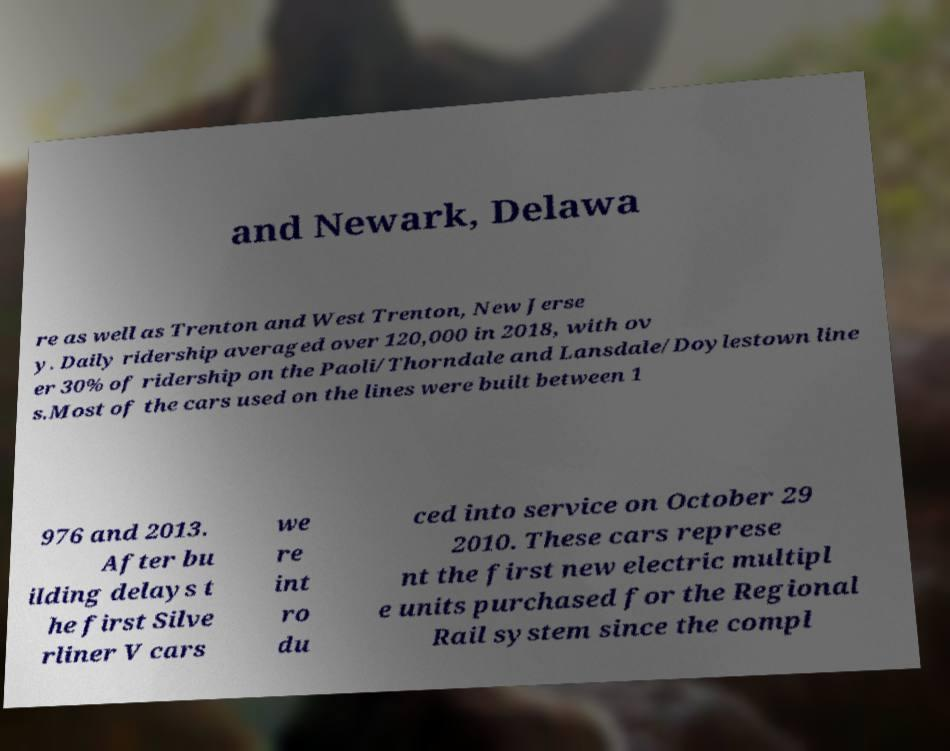Could you assist in decoding the text presented in this image and type it out clearly? and Newark, Delawa re as well as Trenton and West Trenton, New Jerse y. Daily ridership averaged over 120,000 in 2018, with ov er 30% of ridership on the Paoli/Thorndale and Lansdale/Doylestown line s.Most of the cars used on the lines were built between 1 976 and 2013. After bu ilding delays t he first Silve rliner V cars we re int ro du ced into service on October 29 2010. These cars represe nt the first new electric multipl e units purchased for the Regional Rail system since the compl 